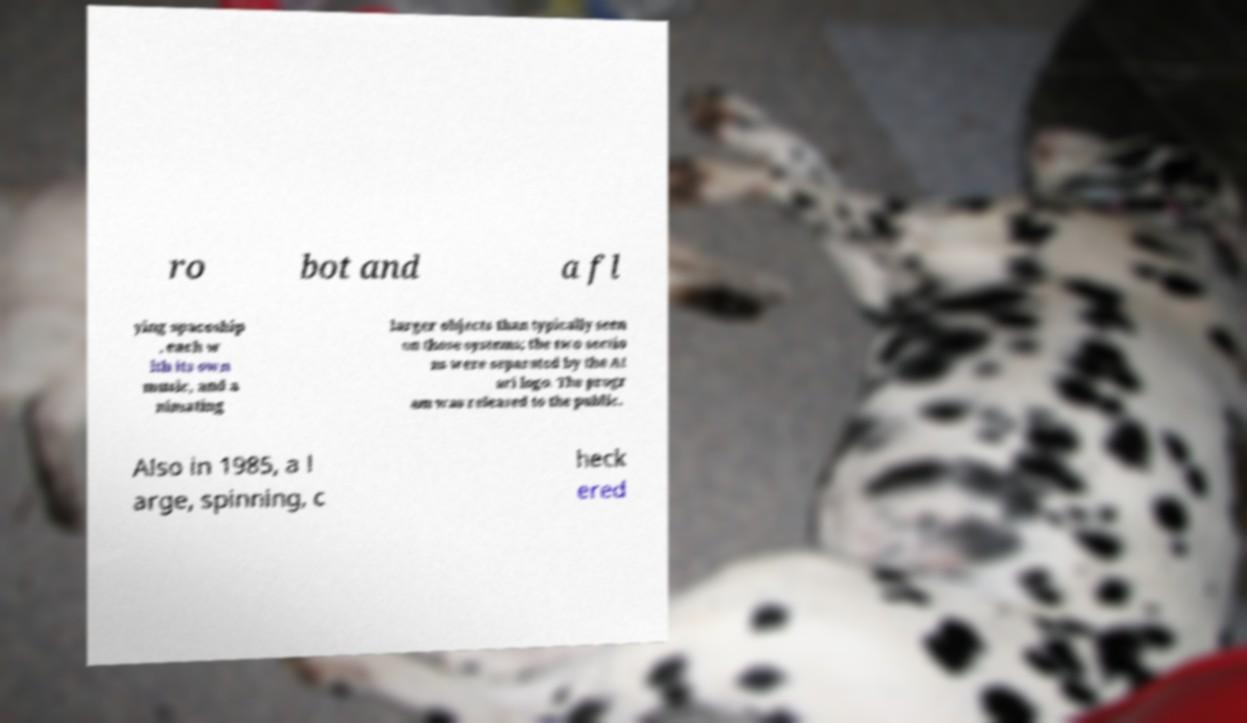I need the written content from this picture converted into text. Can you do that? ro bot and a fl ying spaceship , each w ith its own music, and a nimating larger objects than typically seen on those systems; the two sectio ns were separated by the At ari logo. The progr am was released to the public. Also in 1985, a l arge, spinning, c heck ered 